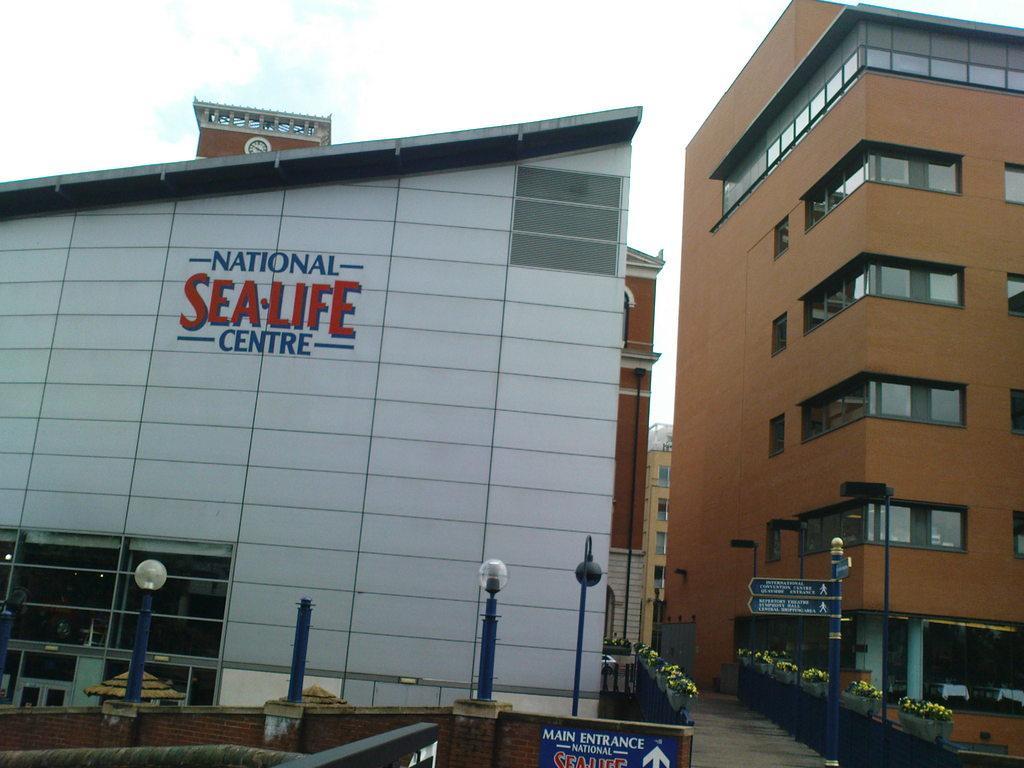How would you summarize this image in a sentence or two? In this image we can see buildings, on the building we can see some text and there are some poles, lights, potted plants, boards with some text and images, flowers and the wall, in the background we can see the sky. 